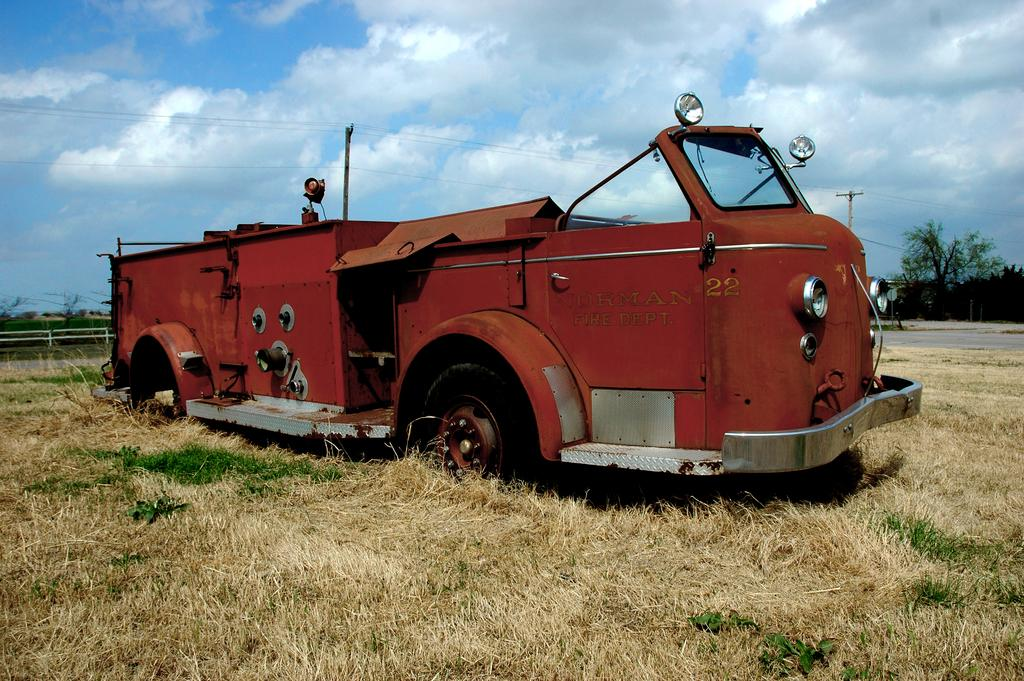What type of vehicle is visible on the grass in the image? The facts do not specify the type of vehicle, but there is a vehicle visible on the grass. What is visible at the top of the image? The sky is visible at the top of the image. What type of vegetation is on the right side of the image? There are trees on the right side of the image. What surface can be seen in the image besides grass? There is a road in the image. What company is responsible for the vehicle in the image? The facts do not provide any information about the company responsible for the vehicle, and there is no indication of a company in the image. How many times does the vehicle smash into the trees in the image? There is no indication of the vehicle smashing into the trees in the image; it is stationary on the grass. 